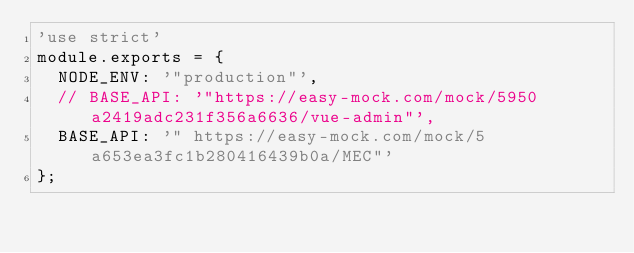Convert code to text. <code><loc_0><loc_0><loc_500><loc_500><_JavaScript_>'use strict'
module.exports = {
  NODE_ENV: '"production"',
  // BASE_API: '"https://easy-mock.com/mock/5950a2419adc231f356a6636/vue-admin"',
  BASE_API: '" https://easy-mock.com/mock/5a653ea3fc1b280416439b0a/MEC"'
};
</code> 